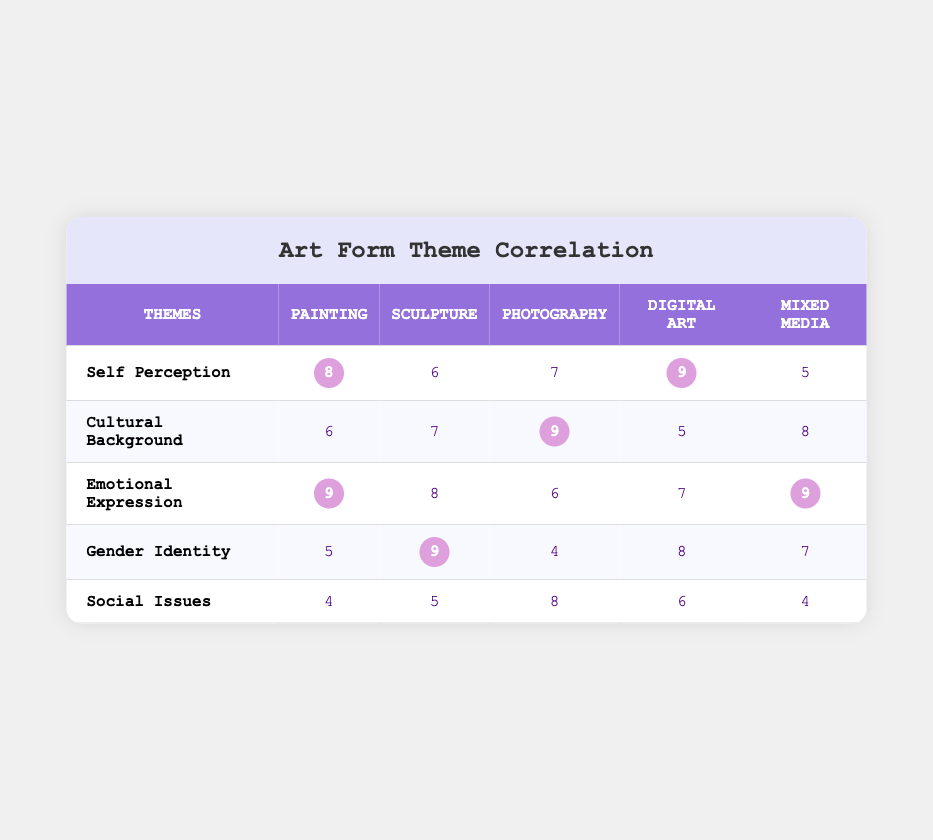What art form has the highest score for Emotional Expression? By reviewing the row for Emotional Expression, we see that Painting and Mixed Media both have the highest score of 9.
Answer: Painting and Mixed Media What is the score for Cultural Background in Photography? Looking at the Photography column under Cultural Background, the score listed is 9.
Answer: 9 Which art form has the lowest score in Self Perception? In the Self Perception row, we compare the scores across art forms and see that Mixed Media has the lowest score of 5.
Answer: Mixed Media What are the average scores for Gender Identity across all art forms? The scores for Gender Identity are 5, 9, 4, 8, and 7. Adding these scores results in 33, and dividing by 5 gives us an average of 6.6.
Answer: 6.6 Is it true that Sculpture has a higher score in Emotional Expression than Photography? Looking at the scores, Sculpture has a score of 8, while Photography has a score of 6. Since 8 is greater than 6, the statement is true.
Answer: Yes Which theme does Photography score the highest in, and what is that score? By checking the scores in the Photography row, we find that the highest score is 9 in Cultural Background.
Answer: Cultural Background, 9 What is the difference between the highest and lowest scores in Social Issues? The highest score in Social Issues is from Photography with 8, and the lowest scores are for Painting and Mixed Media, both with 4. Therefore, the difference is 8 - 4 = 4.
Answer: 4 Which art form exhibits the highest score for Cultural Background? In the Cultural Background row, looking across the different art forms, Photography is rated highest with a score of 9.
Answer: Photography Which theme had a score of 7 in Digital Art? By checking the row for Digital Art, we can see that Emotional Expression has a score of 7.
Answer: Emotional Expression 